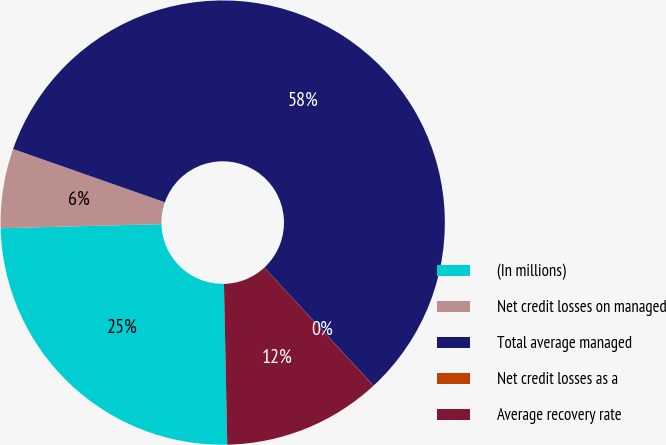Convert chart. <chart><loc_0><loc_0><loc_500><loc_500><pie_chart><fcel>(In millions)<fcel>Net credit losses on managed<fcel>Total average managed<fcel>Net credit losses as a<fcel>Average recovery rate<nl><fcel>24.92%<fcel>5.78%<fcel>57.74%<fcel>0.01%<fcel>11.55%<nl></chart> 